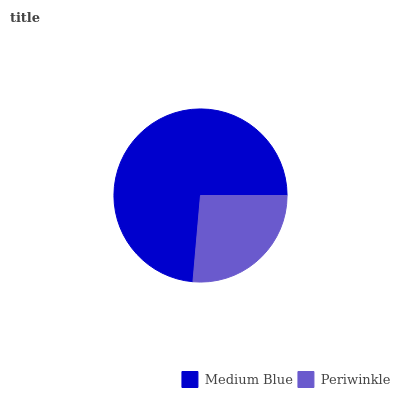Is Periwinkle the minimum?
Answer yes or no. Yes. Is Medium Blue the maximum?
Answer yes or no. Yes. Is Periwinkle the maximum?
Answer yes or no. No. Is Medium Blue greater than Periwinkle?
Answer yes or no. Yes. Is Periwinkle less than Medium Blue?
Answer yes or no. Yes. Is Periwinkle greater than Medium Blue?
Answer yes or no. No. Is Medium Blue less than Periwinkle?
Answer yes or no. No. Is Medium Blue the high median?
Answer yes or no. Yes. Is Periwinkle the low median?
Answer yes or no. Yes. Is Periwinkle the high median?
Answer yes or no. No. Is Medium Blue the low median?
Answer yes or no. No. 